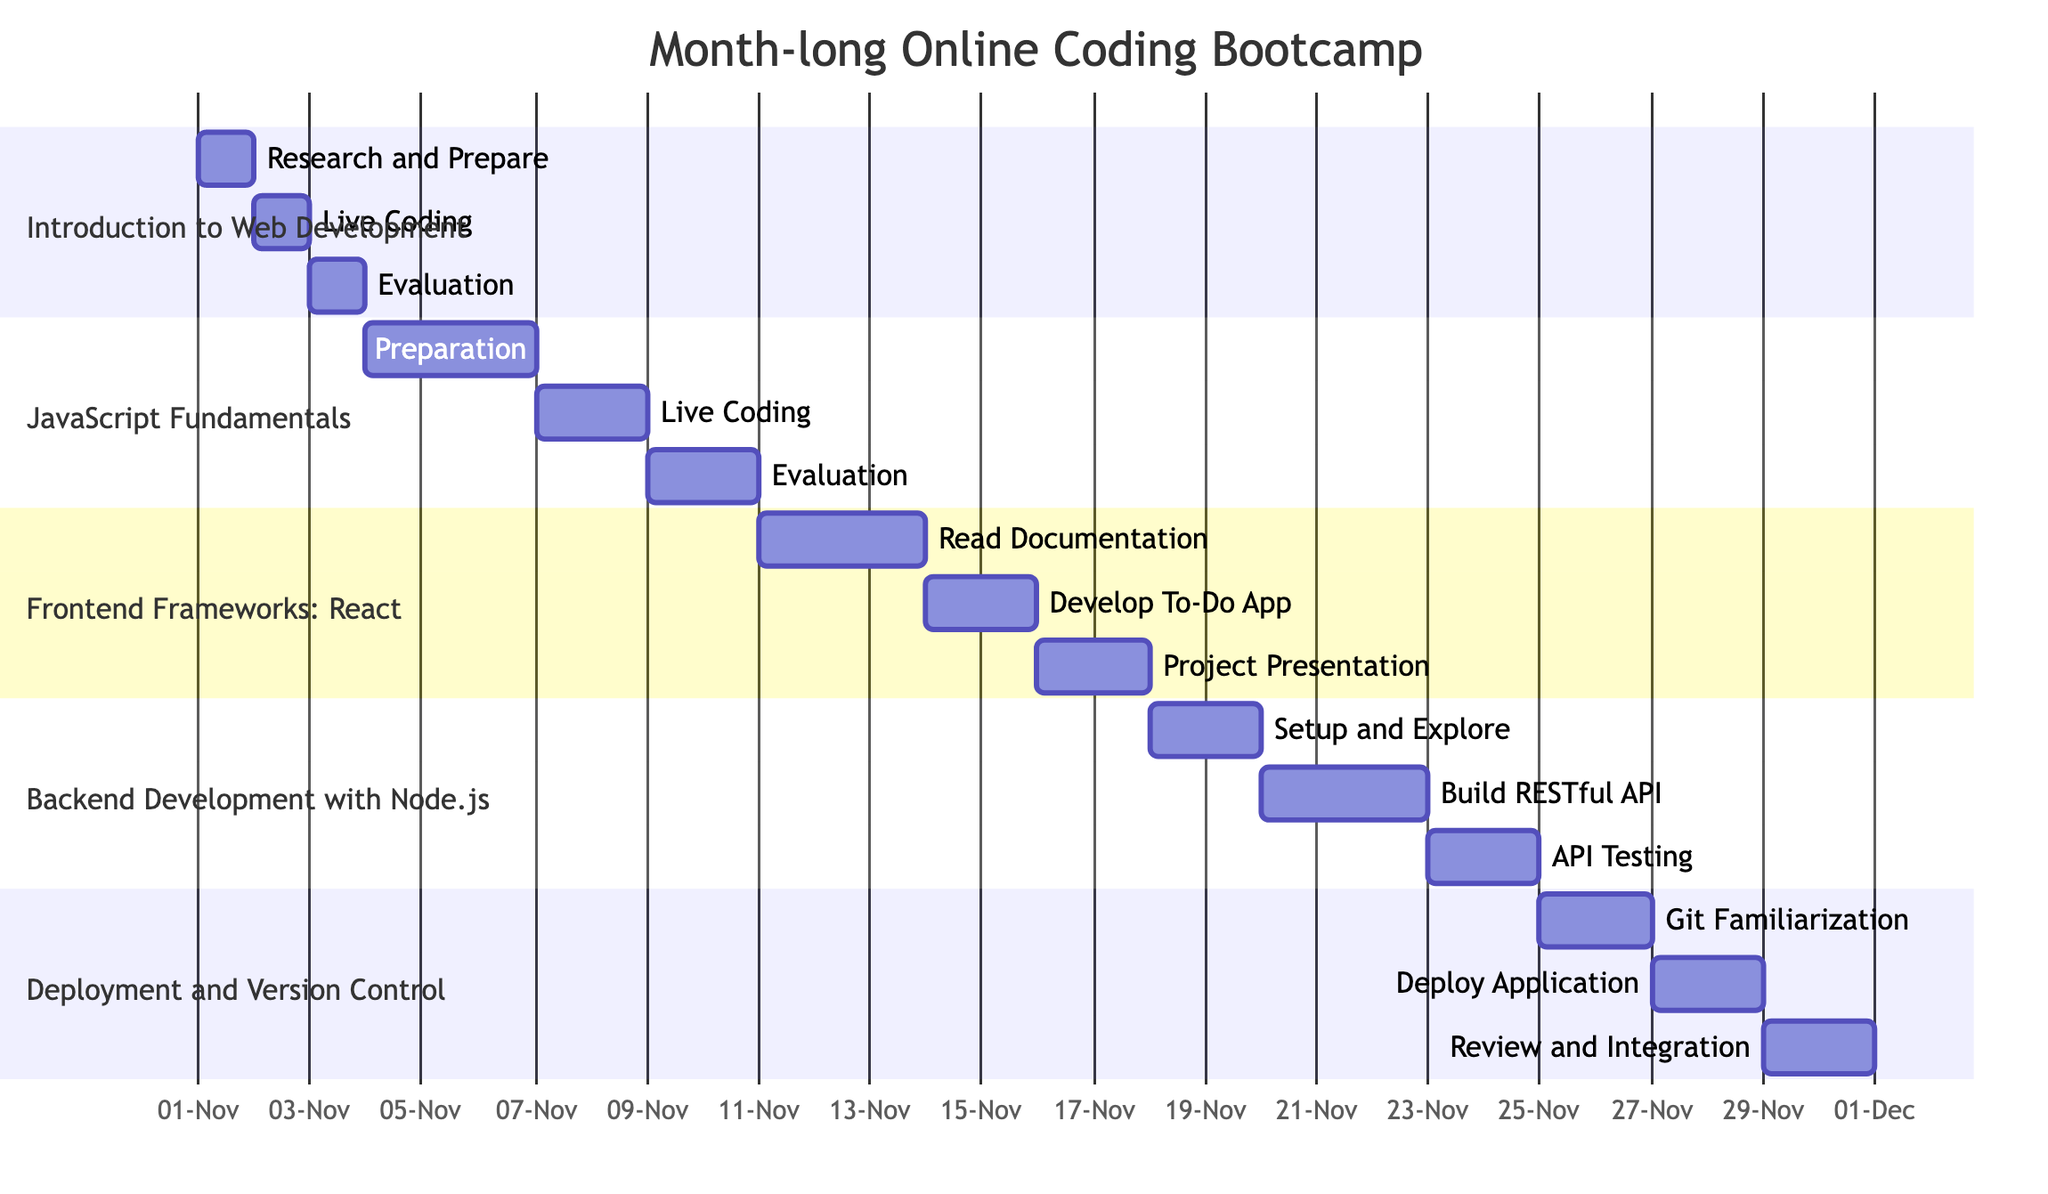What is the duration of the bootcamp? The diagram states that the bootcamp runs for 4 weeks, which is the duration indicated.
Answer: 4 weeks How many live coding exercises are scheduled? By looking at the diagram, I can identify five sessions corresponding to live coding exercises.
Answer: 5 What topic is covered during the week of November 11th? The section for this timeframe shows that the topic is "Frontend Frameworks: React" which starts on November 11th.
Answer: Frontend Frameworks: React On which date does the evaluation for the "JavaScript Fundamentals" take place? Referring to the timeline, the evaluation date for "JavaScript Fundamentals" is specifically marked as November 9th.
Answer: November 9 What preparation activity is scheduled before live coding for "Backend Development with Node.js"? The diagram shows that the preparation activity "Setup and Explore" takes place before the live coding, specifically on November 18th and 19th.
Answer: Setup and Explore How long does the live coding exercise for deploying applications last? The diagram specifies that the deployment live coding exercise is scheduled for 2 days, from November 27th to November 28th.
Answer: 2 days Which topic has a project presentation scheduled? In the chart, it is clear that "Frontend Frameworks: React" includes a project presentation scheduled for November 16th.
Answer: Frontend Frameworks: React What type of evaluation follows the "Backend Development with Node.js" live coding session? The evaluation type following this session is described as "API testing using Postman and peer feedback."
Answer: API Testing When is the Git familiarization scheduled in the bootcamp? The diagram lists "Git Familiarization" as scheduled for November 25th and 26th.
Answer: November 25 